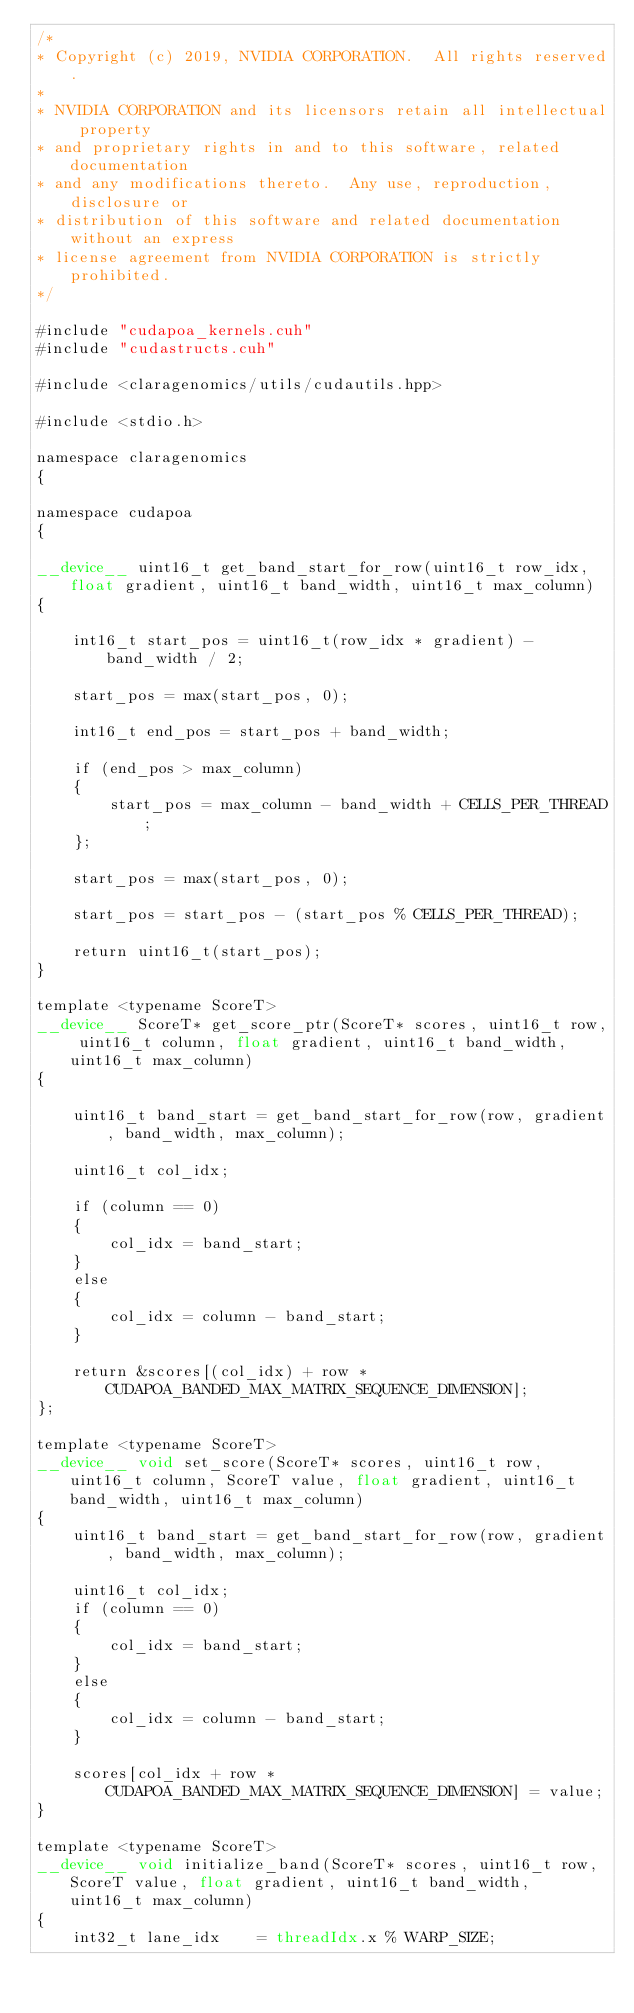Convert code to text. <code><loc_0><loc_0><loc_500><loc_500><_Cuda_>/*
* Copyright (c) 2019, NVIDIA CORPORATION.  All rights reserved.
*
* NVIDIA CORPORATION and its licensors retain all intellectual property
* and proprietary rights in and to this software, related documentation
* and any modifications thereto.  Any use, reproduction, disclosure or
* distribution of this software and related documentation without an express
* license agreement from NVIDIA CORPORATION is strictly prohibited.
*/

#include "cudapoa_kernels.cuh"
#include "cudastructs.cuh"

#include <claragenomics/utils/cudautils.hpp>

#include <stdio.h>

namespace claragenomics
{

namespace cudapoa
{

__device__ uint16_t get_band_start_for_row(uint16_t row_idx, float gradient, uint16_t band_width, uint16_t max_column)
{

    int16_t start_pos = uint16_t(row_idx * gradient) - band_width / 2;

    start_pos = max(start_pos, 0);

    int16_t end_pos = start_pos + band_width;

    if (end_pos > max_column)
    {
        start_pos = max_column - band_width + CELLS_PER_THREAD;
    };

    start_pos = max(start_pos, 0);

    start_pos = start_pos - (start_pos % CELLS_PER_THREAD);

    return uint16_t(start_pos);
}

template <typename ScoreT>
__device__ ScoreT* get_score_ptr(ScoreT* scores, uint16_t row, uint16_t column, float gradient, uint16_t band_width, uint16_t max_column)
{

    uint16_t band_start = get_band_start_for_row(row, gradient, band_width, max_column);

    uint16_t col_idx;

    if (column == 0)
    {
        col_idx = band_start;
    }
    else
    {
        col_idx = column - band_start;
    }

    return &scores[(col_idx) + row * CUDAPOA_BANDED_MAX_MATRIX_SEQUENCE_DIMENSION];
};

template <typename ScoreT>
__device__ void set_score(ScoreT* scores, uint16_t row, uint16_t column, ScoreT value, float gradient, uint16_t band_width, uint16_t max_column)
{
    uint16_t band_start = get_band_start_for_row(row, gradient, band_width, max_column);

    uint16_t col_idx;
    if (column == 0)
    {
        col_idx = band_start;
    }
    else
    {
        col_idx = column - band_start;
    }

    scores[col_idx + row * CUDAPOA_BANDED_MAX_MATRIX_SEQUENCE_DIMENSION] = value;
}

template <typename ScoreT>
__device__ void initialize_band(ScoreT* scores, uint16_t row, ScoreT value, float gradient, uint16_t band_width, uint16_t max_column)
{
    int32_t lane_idx    = threadIdx.x % WARP_SIZE;</code> 